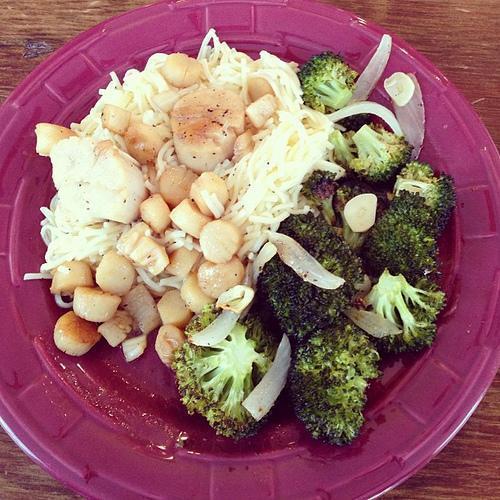How many plates are pictured?
Give a very brief answer. 1. How many vegetables are shown?
Give a very brief answer. 1. 